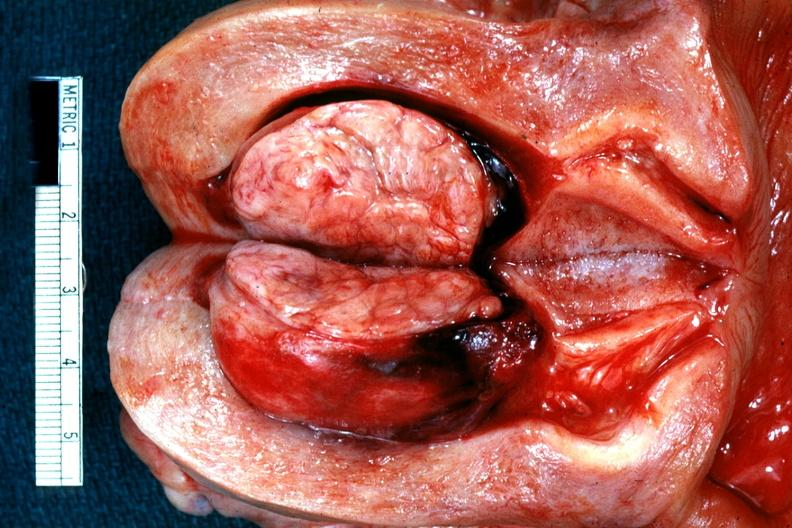what does this image show?
Answer the question using a single word or phrase. Excellent example of submucous myoma 